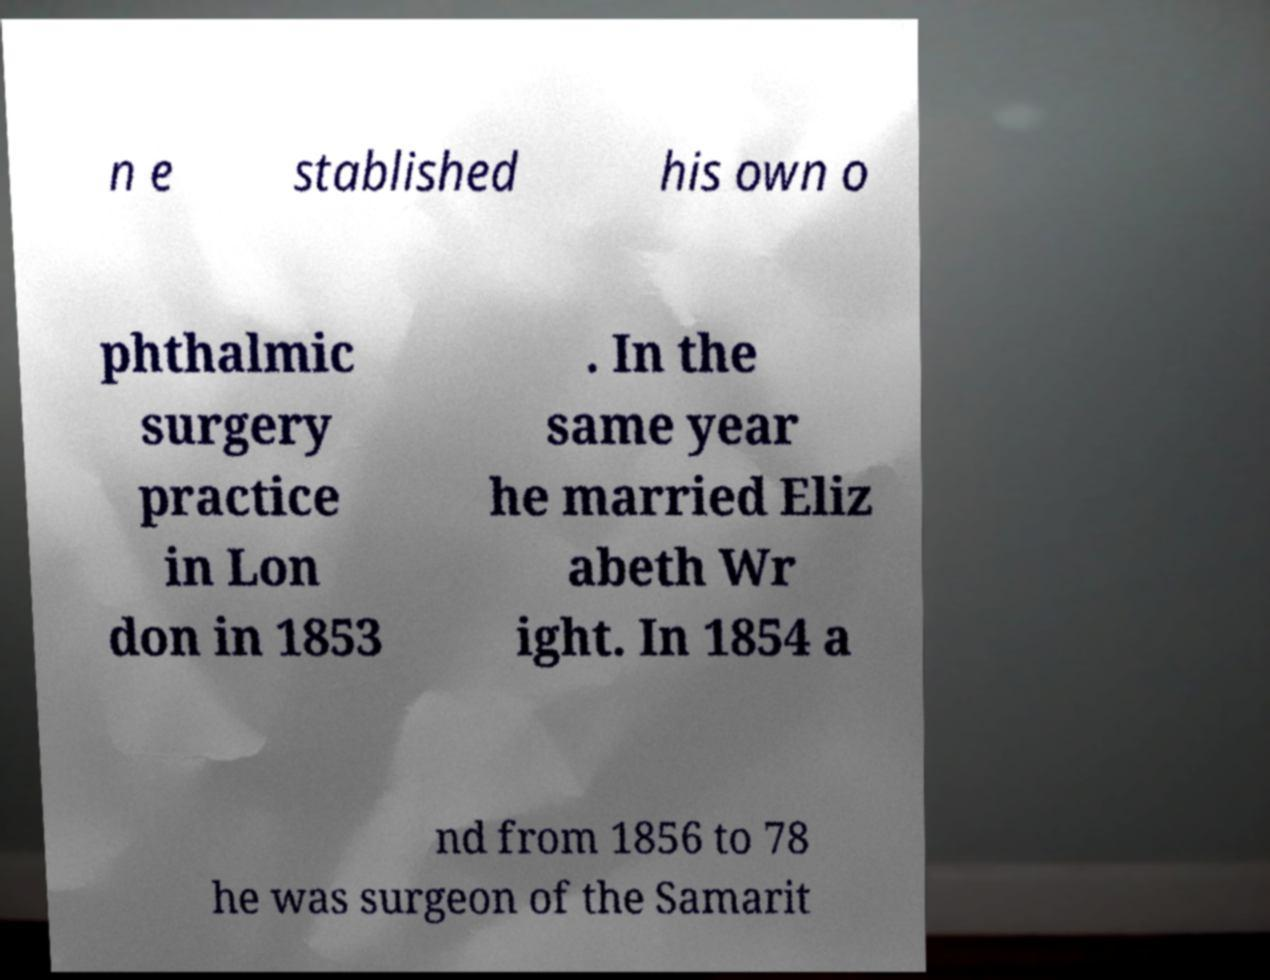There's text embedded in this image that I need extracted. Can you transcribe it verbatim? n e stablished his own o phthalmic surgery practice in Lon don in 1853 . In the same year he married Eliz abeth Wr ight. In 1854 a nd from 1856 to 78 he was surgeon of the Samarit 